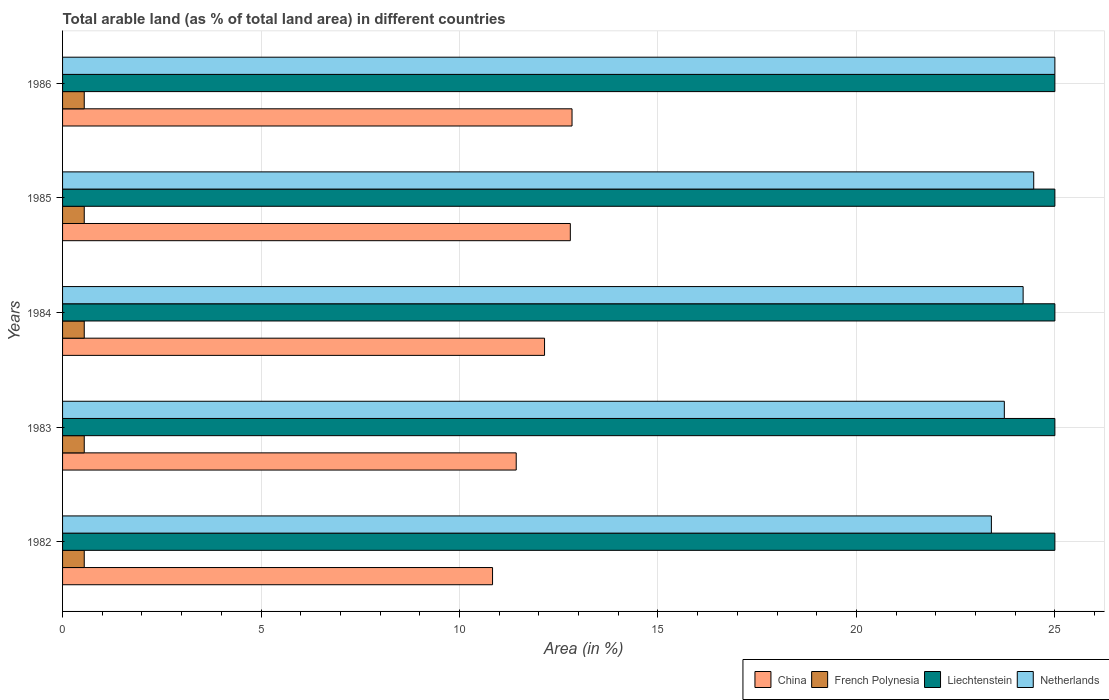How many different coloured bars are there?
Your response must be concise. 4. How many groups of bars are there?
Keep it short and to the point. 5. Are the number of bars per tick equal to the number of legend labels?
Your answer should be very brief. Yes. How many bars are there on the 5th tick from the bottom?
Provide a succinct answer. 4. In how many cases, is the number of bars for a given year not equal to the number of legend labels?
Ensure brevity in your answer.  0. What is the percentage of arable land in China in 1986?
Give a very brief answer. 12.84. Across all years, what is the maximum percentage of arable land in French Polynesia?
Ensure brevity in your answer.  0.55. Across all years, what is the minimum percentage of arable land in French Polynesia?
Your answer should be very brief. 0.55. In which year was the percentage of arable land in Liechtenstein maximum?
Provide a short and direct response. 1982. What is the total percentage of arable land in China in the graph?
Provide a succinct answer. 60.03. What is the difference between the percentage of arable land in China in 1984 and that in 1985?
Provide a short and direct response. -0.65. What is the difference between the percentage of arable land in Liechtenstein in 1984 and the percentage of arable land in Netherlands in 1986?
Make the answer very short. 0. What is the average percentage of arable land in China per year?
Provide a short and direct response. 12.01. In the year 1986, what is the difference between the percentage of arable land in French Polynesia and percentage of arable land in Netherlands?
Offer a very short reply. -24.45. In how many years, is the percentage of arable land in Netherlands greater than 20 %?
Provide a short and direct response. 5. What is the ratio of the percentage of arable land in Liechtenstein in 1985 to that in 1986?
Provide a short and direct response. 1. Is the difference between the percentage of arable land in French Polynesia in 1985 and 1986 greater than the difference between the percentage of arable land in Netherlands in 1985 and 1986?
Keep it short and to the point. Yes. What is the difference between the highest and the second highest percentage of arable land in Netherlands?
Make the answer very short. 0.53. What is the difference between the highest and the lowest percentage of arable land in Liechtenstein?
Provide a succinct answer. 0. Is the sum of the percentage of arable land in French Polynesia in 1982 and 1984 greater than the maximum percentage of arable land in China across all years?
Offer a terse response. No. Is it the case that in every year, the sum of the percentage of arable land in China and percentage of arable land in Netherlands is greater than the sum of percentage of arable land in Liechtenstein and percentage of arable land in French Polynesia?
Provide a short and direct response. No. What does the 2nd bar from the top in 1986 represents?
Offer a very short reply. Liechtenstein. Is it the case that in every year, the sum of the percentage of arable land in Netherlands and percentage of arable land in Liechtenstein is greater than the percentage of arable land in China?
Give a very brief answer. Yes. How many bars are there?
Ensure brevity in your answer.  20. Are all the bars in the graph horizontal?
Keep it short and to the point. Yes. What is the difference between two consecutive major ticks on the X-axis?
Your answer should be very brief. 5. Does the graph contain grids?
Keep it short and to the point. Yes. How are the legend labels stacked?
Offer a very short reply. Horizontal. What is the title of the graph?
Give a very brief answer. Total arable land (as % of total land area) in different countries. Does "Cuba" appear as one of the legend labels in the graph?
Offer a terse response. No. What is the label or title of the X-axis?
Give a very brief answer. Area (in %). What is the Area (in %) of China in 1982?
Keep it short and to the point. 10.83. What is the Area (in %) of French Polynesia in 1982?
Offer a terse response. 0.55. What is the Area (in %) of Netherlands in 1982?
Give a very brief answer. 23.4. What is the Area (in %) of China in 1983?
Your response must be concise. 11.43. What is the Area (in %) in French Polynesia in 1983?
Make the answer very short. 0.55. What is the Area (in %) of Liechtenstein in 1983?
Make the answer very short. 25. What is the Area (in %) in Netherlands in 1983?
Offer a very short reply. 23.73. What is the Area (in %) of China in 1984?
Give a very brief answer. 12.14. What is the Area (in %) in French Polynesia in 1984?
Provide a succinct answer. 0.55. What is the Area (in %) of Netherlands in 1984?
Provide a short and direct response. 24.2. What is the Area (in %) of China in 1985?
Your response must be concise. 12.79. What is the Area (in %) of French Polynesia in 1985?
Give a very brief answer. 0.55. What is the Area (in %) of Liechtenstein in 1985?
Your answer should be compact. 25. What is the Area (in %) in Netherlands in 1985?
Provide a short and direct response. 24.47. What is the Area (in %) in China in 1986?
Provide a succinct answer. 12.84. What is the Area (in %) in French Polynesia in 1986?
Offer a terse response. 0.55. What is the Area (in %) of Netherlands in 1986?
Keep it short and to the point. 25. Across all years, what is the maximum Area (in %) of China?
Provide a succinct answer. 12.84. Across all years, what is the maximum Area (in %) of French Polynesia?
Give a very brief answer. 0.55. Across all years, what is the maximum Area (in %) in Liechtenstein?
Give a very brief answer. 25. Across all years, what is the maximum Area (in %) in Netherlands?
Provide a short and direct response. 25. Across all years, what is the minimum Area (in %) of China?
Provide a short and direct response. 10.83. Across all years, what is the minimum Area (in %) in French Polynesia?
Your answer should be very brief. 0.55. Across all years, what is the minimum Area (in %) in Liechtenstein?
Your answer should be compact. 25. Across all years, what is the minimum Area (in %) in Netherlands?
Your response must be concise. 23.4. What is the total Area (in %) of China in the graph?
Your response must be concise. 60.03. What is the total Area (in %) of French Polynesia in the graph?
Offer a very short reply. 2.73. What is the total Area (in %) in Liechtenstein in the graph?
Your answer should be compact. 125. What is the total Area (in %) of Netherlands in the graph?
Offer a very short reply. 120.79. What is the difference between the Area (in %) in China in 1982 and that in 1983?
Provide a short and direct response. -0.6. What is the difference between the Area (in %) of French Polynesia in 1982 and that in 1983?
Ensure brevity in your answer.  0. What is the difference between the Area (in %) of Liechtenstein in 1982 and that in 1983?
Ensure brevity in your answer.  0. What is the difference between the Area (in %) of Netherlands in 1982 and that in 1983?
Your response must be concise. -0.33. What is the difference between the Area (in %) in China in 1982 and that in 1984?
Your response must be concise. -1.31. What is the difference between the Area (in %) of Liechtenstein in 1982 and that in 1984?
Provide a short and direct response. 0. What is the difference between the Area (in %) of Netherlands in 1982 and that in 1984?
Provide a short and direct response. -0.8. What is the difference between the Area (in %) in China in 1982 and that in 1985?
Offer a very short reply. -1.96. What is the difference between the Area (in %) of French Polynesia in 1982 and that in 1985?
Offer a very short reply. 0. What is the difference between the Area (in %) in Liechtenstein in 1982 and that in 1985?
Provide a short and direct response. 0. What is the difference between the Area (in %) of Netherlands in 1982 and that in 1985?
Offer a very short reply. -1.07. What is the difference between the Area (in %) of China in 1982 and that in 1986?
Keep it short and to the point. -2. What is the difference between the Area (in %) of French Polynesia in 1982 and that in 1986?
Your response must be concise. 0. What is the difference between the Area (in %) in Netherlands in 1982 and that in 1986?
Your answer should be compact. -1.6. What is the difference between the Area (in %) of China in 1983 and that in 1984?
Your answer should be very brief. -0.71. What is the difference between the Area (in %) in French Polynesia in 1983 and that in 1984?
Your answer should be compact. 0. What is the difference between the Area (in %) in Netherlands in 1983 and that in 1984?
Ensure brevity in your answer.  -0.47. What is the difference between the Area (in %) of China in 1983 and that in 1985?
Provide a succinct answer. -1.36. What is the difference between the Area (in %) in Netherlands in 1983 and that in 1985?
Your answer should be very brief. -0.74. What is the difference between the Area (in %) of China in 1983 and that in 1986?
Provide a short and direct response. -1.41. What is the difference between the Area (in %) of French Polynesia in 1983 and that in 1986?
Provide a succinct answer. 0. What is the difference between the Area (in %) of Liechtenstein in 1983 and that in 1986?
Offer a very short reply. 0. What is the difference between the Area (in %) in Netherlands in 1983 and that in 1986?
Offer a terse response. -1.27. What is the difference between the Area (in %) of China in 1984 and that in 1985?
Offer a terse response. -0.65. What is the difference between the Area (in %) of French Polynesia in 1984 and that in 1985?
Provide a short and direct response. 0. What is the difference between the Area (in %) in Liechtenstein in 1984 and that in 1985?
Your answer should be very brief. 0. What is the difference between the Area (in %) in Netherlands in 1984 and that in 1985?
Your response must be concise. -0.27. What is the difference between the Area (in %) in China in 1984 and that in 1986?
Your answer should be compact. -0.69. What is the difference between the Area (in %) in French Polynesia in 1984 and that in 1986?
Give a very brief answer. 0. What is the difference between the Area (in %) of Liechtenstein in 1984 and that in 1986?
Keep it short and to the point. 0. What is the difference between the Area (in %) of Netherlands in 1984 and that in 1986?
Provide a short and direct response. -0.8. What is the difference between the Area (in %) in China in 1985 and that in 1986?
Give a very brief answer. -0.04. What is the difference between the Area (in %) of French Polynesia in 1985 and that in 1986?
Your response must be concise. 0. What is the difference between the Area (in %) of Liechtenstein in 1985 and that in 1986?
Give a very brief answer. 0. What is the difference between the Area (in %) of Netherlands in 1985 and that in 1986?
Ensure brevity in your answer.  -0.53. What is the difference between the Area (in %) in China in 1982 and the Area (in %) in French Polynesia in 1983?
Ensure brevity in your answer.  10.29. What is the difference between the Area (in %) of China in 1982 and the Area (in %) of Liechtenstein in 1983?
Keep it short and to the point. -14.17. What is the difference between the Area (in %) of China in 1982 and the Area (in %) of Netherlands in 1983?
Provide a short and direct response. -12.89. What is the difference between the Area (in %) in French Polynesia in 1982 and the Area (in %) in Liechtenstein in 1983?
Provide a succinct answer. -24.45. What is the difference between the Area (in %) of French Polynesia in 1982 and the Area (in %) of Netherlands in 1983?
Offer a terse response. -23.18. What is the difference between the Area (in %) of Liechtenstein in 1982 and the Area (in %) of Netherlands in 1983?
Your response must be concise. 1.27. What is the difference between the Area (in %) in China in 1982 and the Area (in %) in French Polynesia in 1984?
Offer a very short reply. 10.29. What is the difference between the Area (in %) of China in 1982 and the Area (in %) of Liechtenstein in 1984?
Offer a terse response. -14.17. What is the difference between the Area (in %) of China in 1982 and the Area (in %) of Netherlands in 1984?
Give a very brief answer. -13.37. What is the difference between the Area (in %) in French Polynesia in 1982 and the Area (in %) in Liechtenstein in 1984?
Ensure brevity in your answer.  -24.45. What is the difference between the Area (in %) in French Polynesia in 1982 and the Area (in %) in Netherlands in 1984?
Make the answer very short. -23.65. What is the difference between the Area (in %) of Liechtenstein in 1982 and the Area (in %) of Netherlands in 1984?
Make the answer very short. 0.8. What is the difference between the Area (in %) in China in 1982 and the Area (in %) in French Polynesia in 1985?
Make the answer very short. 10.29. What is the difference between the Area (in %) of China in 1982 and the Area (in %) of Liechtenstein in 1985?
Ensure brevity in your answer.  -14.17. What is the difference between the Area (in %) in China in 1982 and the Area (in %) in Netherlands in 1985?
Provide a succinct answer. -13.63. What is the difference between the Area (in %) in French Polynesia in 1982 and the Area (in %) in Liechtenstein in 1985?
Offer a very short reply. -24.45. What is the difference between the Area (in %) of French Polynesia in 1982 and the Area (in %) of Netherlands in 1985?
Keep it short and to the point. -23.92. What is the difference between the Area (in %) in Liechtenstein in 1982 and the Area (in %) in Netherlands in 1985?
Make the answer very short. 0.53. What is the difference between the Area (in %) in China in 1982 and the Area (in %) in French Polynesia in 1986?
Make the answer very short. 10.29. What is the difference between the Area (in %) of China in 1982 and the Area (in %) of Liechtenstein in 1986?
Your response must be concise. -14.17. What is the difference between the Area (in %) of China in 1982 and the Area (in %) of Netherlands in 1986?
Your answer should be very brief. -14.17. What is the difference between the Area (in %) in French Polynesia in 1982 and the Area (in %) in Liechtenstein in 1986?
Ensure brevity in your answer.  -24.45. What is the difference between the Area (in %) in French Polynesia in 1982 and the Area (in %) in Netherlands in 1986?
Your answer should be compact. -24.45. What is the difference between the Area (in %) in China in 1983 and the Area (in %) in French Polynesia in 1984?
Give a very brief answer. 10.88. What is the difference between the Area (in %) of China in 1983 and the Area (in %) of Liechtenstein in 1984?
Keep it short and to the point. -13.57. What is the difference between the Area (in %) of China in 1983 and the Area (in %) of Netherlands in 1984?
Ensure brevity in your answer.  -12.77. What is the difference between the Area (in %) of French Polynesia in 1983 and the Area (in %) of Liechtenstein in 1984?
Make the answer very short. -24.45. What is the difference between the Area (in %) of French Polynesia in 1983 and the Area (in %) of Netherlands in 1984?
Your response must be concise. -23.65. What is the difference between the Area (in %) in Liechtenstein in 1983 and the Area (in %) in Netherlands in 1984?
Offer a terse response. 0.8. What is the difference between the Area (in %) in China in 1983 and the Area (in %) in French Polynesia in 1985?
Give a very brief answer. 10.88. What is the difference between the Area (in %) of China in 1983 and the Area (in %) of Liechtenstein in 1985?
Provide a short and direct response. -13.57. What is the difference between the Area (in %) of China in 1983 and the Area (in %) of Netherlands in 1985?
Your answer should be compact. -13.04. What is the difference between the Area (in %) in French Polynesia in 1983 and the Area (in %) in Liechtenstein in 1985?
Provide a succinct answer. -24.45. What is the difference between the Area (in %) of French Polynesia in 1983 and the Area (in %) of Netherlands in 1985?
Your answer should be compact. -23.92. What is the difference between the Area (in %) in Liechtenstein in 1983 and the Area (in %) in Netherlands in 1985?
Keep it short and to the point. 0.53. What is the difference between the Area (in %) of China in 1983 and the Area (in %) of French Polynesia in 1986?
Offer a terse response. 10.88. What is the difference between the Area (in %) in China in 1983 and the Area (in %) in Liechtenstein in 1986?
Give a very brief answer. -13.57. What is the difference between the Area (in %) in China in 1983 and the Area (in %) in Netherlands in 1986?
Provide a succinct answer. -13.57. What is the difference between the Area (in %) in French Polynesia in 1983 and the Area (in %) in Liechtenstein in 1986?
Your answer should be compact. -24.45. What is the difference between the Area (in %) of French Polynesia in 1983 and the Area (in %) of Netherlands in 1986?
Give a very brief answer. -24.45. What is the difference between the Area (in %) of China in 1984 and the Area (in %) of French Polynesia in 1985?
Provide a succinct answer. 11.6. What is the difference between the Area (in %) of China in 1984 and the Area (in %) of Liechtenstein in 1985?
Ensure brevity in your answer.  -12.86. What is the difference between the Area (in %) of China in 1984 and the Area (in %) of Netherlands in 1985?
Offer a terse response. -12.32. What is the difference between the Area (in %) of French Polynesia in 1984 and the Area (in %) of Liechtenstein in 1985?
Make the answer very short. -24.45. What is the difference between the Area (in %) in French Polynesia in 1984 and the Area (in %) in Netherlands in 1985?
Provide a succinct answer. -23.92. What is the difference between the Area (in %) in Liechtenstein in 1984 and the Area (in %) in Netherlands in 1985?
Give a very brief answer. 0.53. What is the difference between the Area (in %) of China in 1984 and the Area (in %) of French Polynesia in 1986?
Your answer should be compact. 11.6. What is the difference between the Area (in %) in China in 1984 and the Area (in %) in Liechtenstein in 1986?
Your response must be concise. -12.86. What is the difference between the Area (in %) of China in 1984 and the Area (in %) of Netherlands in 1986?
Keep it short and to the point. -12.86. What is the difference between the Area (in %) of French Polynesia in 1984 and the Area (in %) of Liechtenstein in 1986?
Provide a short and direct response. -24.45. What is the difference between the Area (in %) of French Polynesia in 1984 and the Area (in %) of Netherlands in 1986?
Offer a very short reply. -24.45. What is the difference between the Area (in %) of Liechtenstein in 1984 and the Area (in %) of Netherlands in 1986?
Provide a succinct answer. 0. What is the difference between the Area (in %) in China in 1985 and the Area (in %) in French Polynesia in 1986?
Your answer should be compact. 12.25. What is the difference between the Area (in %) in China in 1985 and the Area (in %) in Liechtenstein in 1986?
Give a very brief answer. -12.21. What is the difference between the Area (in %) in China in 1985 and the Area (in %) in Netherlands in 1986?
Make the answer very short. -12.21. What is the difference between the Area (in %) of French Polynesia in 1985 and the Area (in %) of Liechtenstein in 1986?
Provide a short and direct response. -24.45. What is the difference between the Area (in %) in French Polynesia in 1985 and the Area (in %) in Netherlands in 1986?
Give a very brief answer. -24.45. What is the difference between the Area (in %) of Liechtenstein in 1985 and the Area (in %) of Netherlands in 1986?
Offer a terse response. 0. What is the average Area (in %) in China per year?
Keep it short and to the point. 12.01. What is the average Area (in %) of French Polynesia per year?
Give a very brief answer. 0.55. What is the average Area (in %) of Netherlands per year?
Offer a terse response. 24.16. In the year 1982, what is the difference between the Area (in %) of China and Area (in %) of French Polynesia?
Ensure brevity in your answer.  10.29. In the year 1982, what is the difference between the Area (in %) in China and Area (in %) in Liechtenstein?
Offer a terse response. -14.17. In the year 1982, what is the difference between the Area (in %) of China and Area (in %) of Netherlands?
Your answer should be very brief. -12.57. In the year 1982, what is the difference between the Area (in %) in French Polynesia and Area (in %) in Liechtenstein?
Give a very brief answer. -24.45. In the year 1982, what is the difference between the Area (in %) in French Polynesia and Area (in %) in Netherlands?
Offer a very short reply. -22.85. In the year 1982, what is the difference between the Area (in %) in Liechtenstein and Area (in %) in Netherlands?
Provide a succinct answer. 1.6. In the year 1983, what is the difference between the Area (in %) of China and Area (in %) of French Polynesia?
Your answer should be very brief. 10.88. In the year 1983, what is the difference between the Area (in %) in China and Area (in %) in Liechtenstein?
Make the answer very short. -13.57. In the year 1983, what is the difference between the Area (in %) of China and Area (in %) of Netherlands?
Your response must be concise. -12.3. In the year 1983, what is the difference between the Area (in %) of French Polynesia and Area (in %) of Liechtenstein?
Your response must be concise. -24.45. In the year 1983, what is the difference between the Area (in %) in French Polynesia and Area (in %) in Netherlands?
Your answer should be very brief. -23.18. In the year 1983, what is the difference between the Area (in %) of Liechtenstein and Area (in %) of Netherlands?
Your response must be concise. 1.27. In the year 1984, what is the difference between the Area (in %) in China and Area (in %) in French Polynesia?
Your answer should be very brief. 11.6. In the year 1984, what is the difference between the Area (in %) in China and Area (in %) in Liechtenstein?
Your response must be concise. -12.86. In the year 1984, what is the difference between the Area (in %) of China and Area (in %) of Netherlands?
Ensure brevity in your answer.  -12.06. In the year 1984, what is the difference between the Area (in %) of French Polynesia and Area (in %) of Liechtenstein?
Provide a short and direct response. -24.45. In the year 1984, what is the difference between the Area (in %) of French Polynesia and Area (in %) of Netherlands?
Provide a short and direct response. -23.65. In the year 1984, what is the difference between the Area (in %) in Liechtenstein and Area (in %) in Netherlands?
Offer a very short reply. 0.8. In the year 1985, what is the difference between the Area (in %) of China and Area (in %) of French Polynesia?
Provide a short and direct response. 12.25. In the year 1985, what is the difference between the Area (in %) of China and Area (in %) of Liechtenstein?
Make the answer very short. -12.21. In the year 1985, what is the difference between the Area (in %) in China and Area (in %) in Netherlands?
Provide a succinct answer. -11.67. In the year 1985, what is the difference between the Area (in %) in French Polynesia and Area (in %) in Liechtenstein?
Your answer should be compact. -24.45. In the year 1985, what is the difference between the Area (in %) of French Polynesia and Area (in %) of Netherlands?
Provide a short and direct response. -23.92. In the year 1985, what is the difference between the Area (in %) in Liechtenstein and Area (in %) in Netherlands?
Provide a short and direct response. 0.53. In the year 1986, what is the difference between the Area (in %) of China and Area (in %) of French Polynesia?
Provide a succinct answer. 12.29. In the year 1986, what is the difference between the Area (in %) in China and Area (in %) in Liechtenstein?
Offer a very short reply. -12.16. In the year 1986, what is the difference between the Area (in %) of China and Area (in %) of Netherlands?
Offer a very short reply. -12.16. In the year 1986, what is the difference between the Area (in %) in French Polynesia and Area (in %) in Liechtenstein?
Offer a terse response. -24.45. In the year 1986, what is the difference between the Area (in %) of French Polynesia and Area (in %) of Netherlands?
Ensure brevity in your answer.  -24.45. In the year 1986, what is the difference between the Area (in %) of Liechtenstein and Area (in %) of Netherlands?
Provide a succinct answer. 0. What is the ratio of the Area (in %) of China in 1982 to that in 1983?
Provide a succinct answer. 0.95. What is the ratio of the Area (in %) of French Polynesia in 1982 to that in 1983?
Your response must be concise. 1. What is the ratio of the Area (in %) in Liechtenstein in 1982 to that in 1983?
Make the answer very short. 1. What is the ratio of the Area (in %) in Netherlands in 1982 to that in 1983?
Your response must be concise. 0.99. What is the ratio of the Area (in %) in China in 1982 to that in 1984?
Give a very brief answer. 0.89. What is the ratio of the Area (in %) of Liechtenstein in 1982 to that in 1984?
Offer a very short reply. 1. What is the ratio of the Area (in %) of Netherlands in 1982 to that in 1984?
Your answer should be very brief. 0.97. What is the ratio of the Area (in %) of China in 1982 to that in 1985?
Provide a succinct answer. 0.85. What is the ratio of the Area (in %) in French Polynesia in 1982 to that in 1985?
Keep it short and to the point. 1. What is the ratio of the Area (in %) in Liechtenstein in 1982 to that in 1985?
Offer a terse response. 1. What is the ratio of the Area (in %) of Netherlands in 1982 to that in 1985?
Your response must be concise. 0.96. What is the ratio of the Area (in %) in China in 1982 to that in 1986?
Keep it short and to the point. 0.84. What is the ratio of the Area (in %) of Liechtenstein in 1982 to that in 1986?
Give a very brief answer. 1. What is the ratio of the Area (in %) of Netherlands in 1982 to that in 1986?
Ensure brevity in your answer.  0.94. What is the ratio of the Area (in %) in Netherlands in 1983 to that in 1984?
Your response must be concise. 0.98. What is the ratio of the Area (in %) of China in 1983 to that in 1985?
Provide a succinct answer. 0.89. What is the ratio of the Area (in %) of French Polynesia in 1983 to that in 1985?
Provide a succinct answer. 1. What is the ratio of the Area (in %) in Liechtenstein in 1983 to that in 1985?
Provide a succinct answer. 1. What is the ratio of the Area (in %) in Netherlands in 1983 to that in 1985?
Your answer should be compact. 0.97. What is the ratio of the Area (in %) in China in 1983 to that in 1986?
Provide a succinct answer. 0.89. What is the ratio of the Area (in %) in French Polynesia in 1983 to that in 1986?
Offer a very short reply. 1. What is the ratio of the Area (in %) of Netherlands in 1983 to that in 1986?
Give a very brief answer. 0.95. What is the ratio of the Area (in %) in China in 1984 to that in 1985?
Make the answer very short. 0.95. What is the ratio of the Area (in %) in China in 1984 to that in 1986?
Ensure brevity in your answer.  0.95. What is the ratio of the Area (in %) in Netherlands in 1984 to that in 1986?
Your answer should be compact. 0.97. What is the ratio of the Area (in %) in Liechtenstein in 1985 to that in 1986?
Make the answer very short. 1. What is the ratio of the Area (in %) in Netherlands in 1985 to that in 1986?
Provide a succinct answer. 0.98. What is the difference between the highest and the second highest Area (in %) in China?
Offer a very short reply. 0.04. What is the difference between the highest and the second highest Area (in %) of Liechtenstein?
Make the answer very short. 0. What is the difference between the highest and the second highest Area (in %) in Netherlands?
Provide a succinct answer. 0.53. What is the difference between the highest and the lowest Area (in %) in China?
Offer a terse response. 2. What is the difference between the highest and the lowest Area (in %) in French Polynesia?
Provide a succinct answer. 0. What is the difference between the highest and the lowest Area (in %) in Netherlands?
Provide a succinct answer. 1.6. 